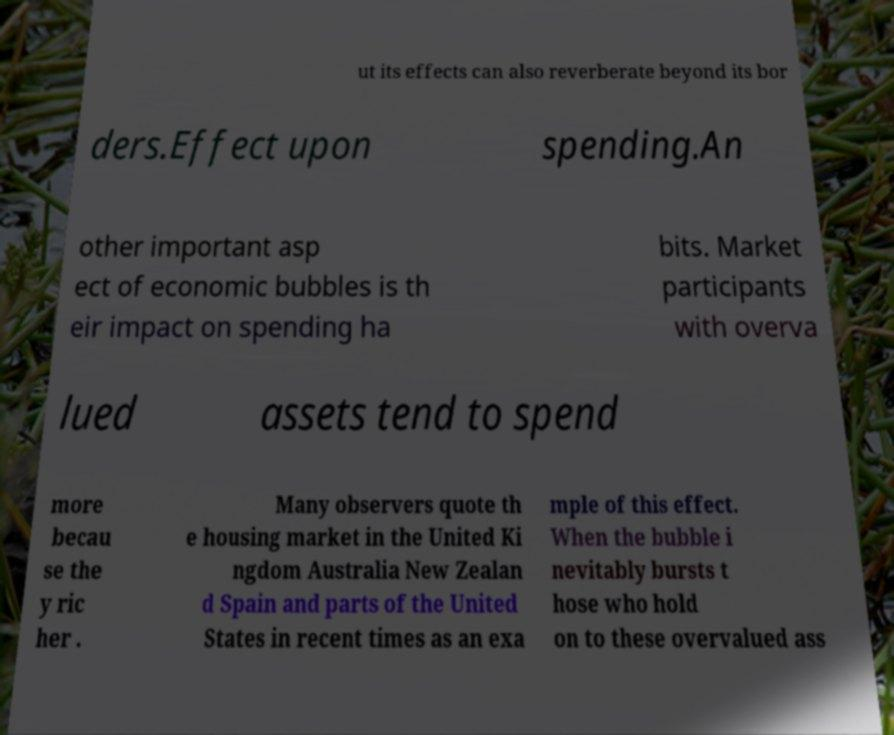What messages or text are displayed in this image? I need them in a readable, typed format. ut its effects can also reverberate beyond its bor ders.Effect upon spending.An other important asp ect of economic bubbles is th eir impact on spending ha bits. Market participants with overva lued assets tend to spend more becau se the y ric her . Many observers quote th e housing market in the United Ki ngdom Australia New Zealan d Spain and parts of the United States in recent times as an exa mple of this effect. When the bubble i nevitably bursts t hose who hold on to these overvalued ass 